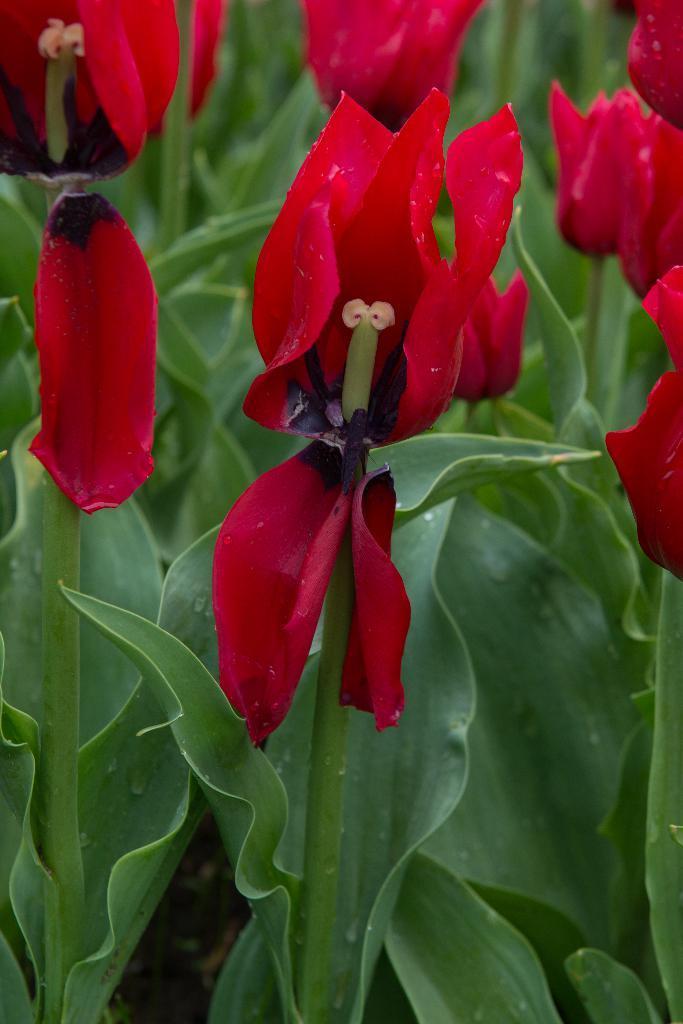How would you summarize this image in a sentence or two? Here we can see flowers and plants. 